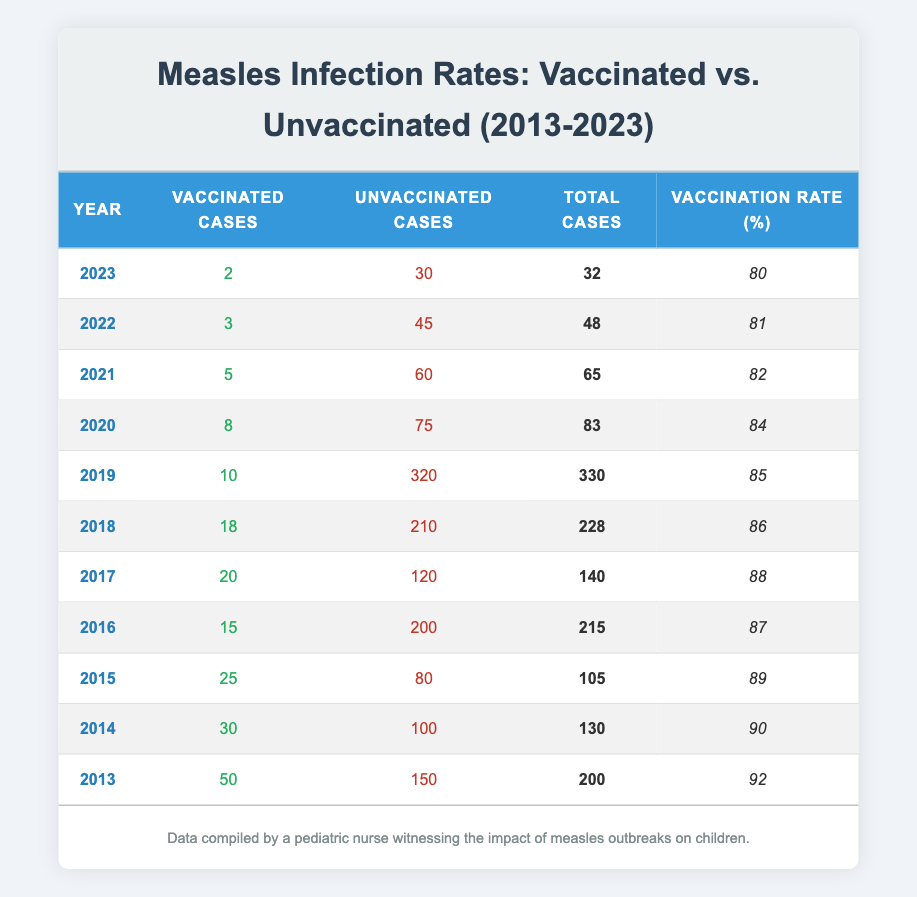What was the total number of measles cases in 2018? From the table, I can find the row for the year 2018, which indicates that the total cases that year were 228.
Answer: 228 How many unvaccinated cases were reported in 2015? By looking at the row for the year 2015, it shows that there were 80 reported cases among unvaccinated children.
Answer: 80 What is the vaccination rate in 2023 compared to 2013? The vaccination rate for 2023 is 80%, and for 2013 it is 92%. The comparison shows a decrease over the decade from 92% to 80%.
Answer: Decreased In which year did the number of vaccinated cases drop below 10? I search through the years in the table and find that the number of vaccinated cases fell below 10 in both 2019 (10) and 2020 (8).
Answer: 2020 What is the average number of unvaccinated cases from 2013 to 2023? I add the unvaccinated cases for each year from the table: 150 + 100 + 80 + 200 + 120 + 210 + 320 + 75 + 60 + 45 + 30 = 1,490. Then I divide by 11 years: 1,490 / 11 = approximately 135.45.
Answer: Approximately 135 Did the number of total measles cases increase or decrease from 2013 to 2023? By comparing the total cases in 2013 (200) and 2023 (32), it's clear that there is a significant decrease in the number of measles cases over the decade.
Answer: Decreased What percentage of total cases were vaccinated cases in 2016? For 2016, the number of vaccinated cases was 15 out of a total of 215 cases. To find the percentage, I calculate (15/215) * 100, which gives approximately 6.98%.
Answer: Approximately 6.98% Which year saw the highest number of total measles cases, and what was that number? I review the total cases column and see that 2019 had the highest number with 330 total cases.
Answer: 2019, 330 How many more cases were reported in unvaccinated children compared to vaccinated children in 2019? For 2019, the number of unvaccinated cases was 320 and vaccinated cases were 10. The difference is 320 - 10 = 310 more cases among unvaccinated children.
Answer: 310 